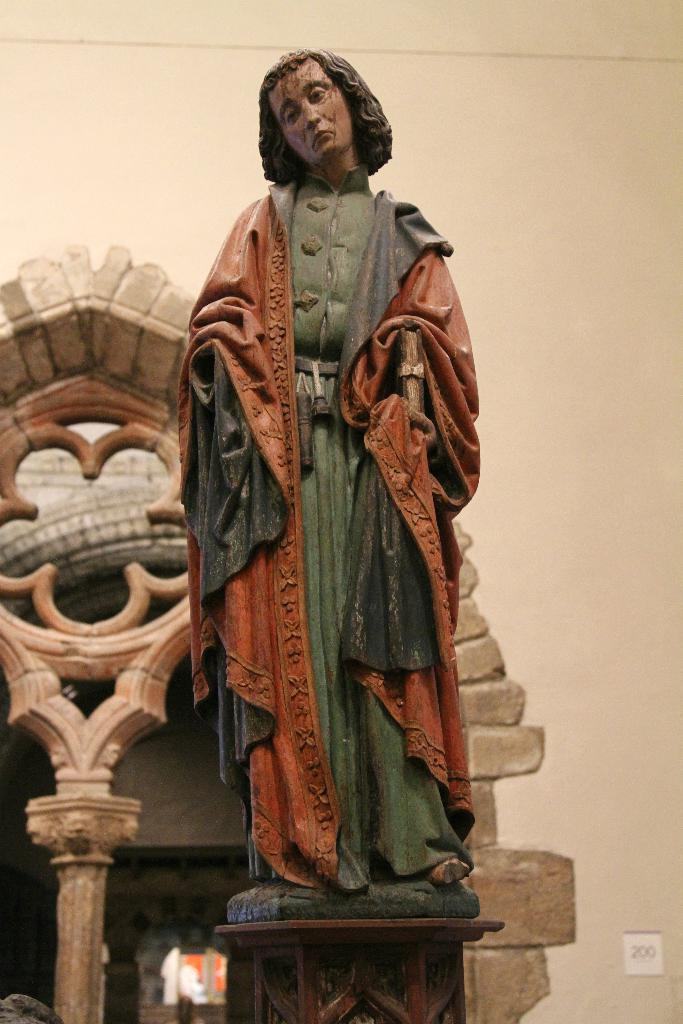What is the main subject in the image? There is a statue in the image. How is the statue positioned? The statue is standing. What can be seen in the background of the image? There is a wall in the background of the image. Are there any architectural features associated with the wall? Yes, there is a pillar associated with the wall in the background of the image. What type of trade is being conducted in the image? There is no indication of any trade being conducted in the image; it features a statue standing in front of a wall with a pillar. What type of pest can be seen crawling on the statue in the image? There are no pests visible on the statue in the image. 